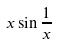<formula> <loc_0><loc_0><loc_500><loc_500>x \sin \frac { 1 } { x }</formula> 